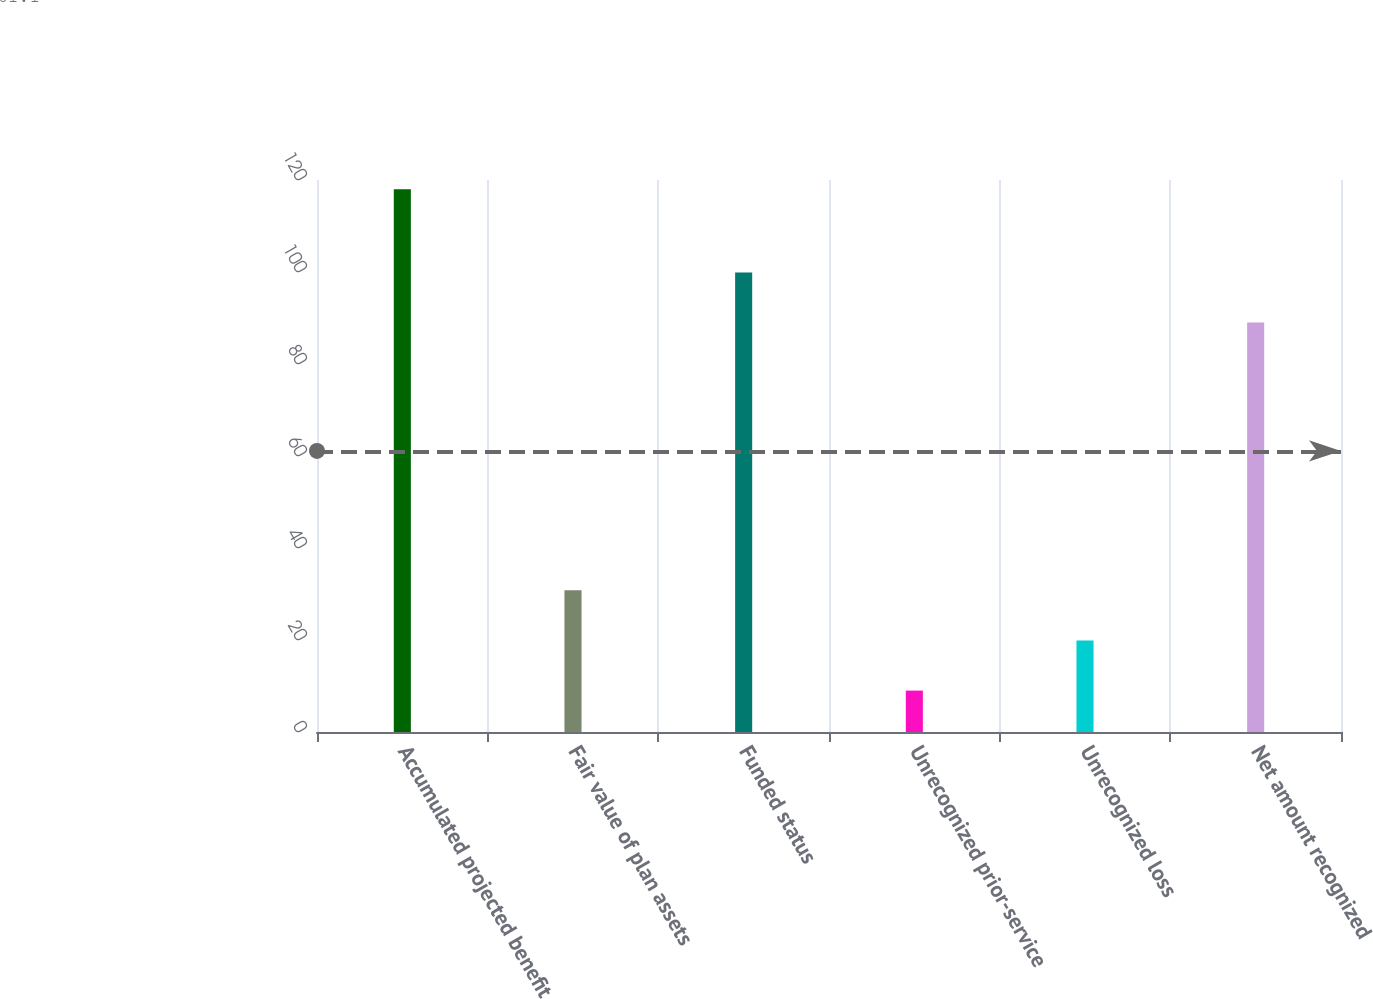Convert chart. <chart><loc_0><loc_0><loc_500><loc_500><bar_chart><fcel>Accumulated projected benefit<fcel>Fair value of plan assets<fcel>Funded status<fcel>Unrecognized prior-service<fcel>Unrecognized loss<fcel>Net amount recognized<nl><fcel>118<fcel>30.8<fcel>99.9<fcel>9<fcel>19.9<fcel>89<nl></chart> 